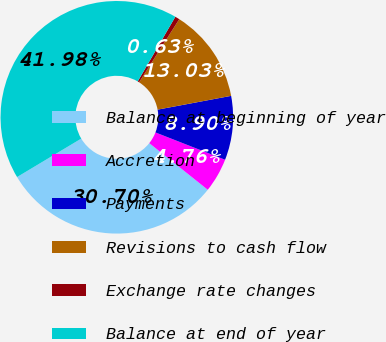Convert chart to OTSL. <chart><loc_0><loc_0><loc_500><loc_500><pie_chart><fcel>Balance at beginning of year<fcel>Accretion<fcel>Payments<fcel>Revisions to cash flow<fcel>Exchange rate changes<fcel>Balance at end of year<nl><fcel>30.7%<fcel>4.76%<fcel>8.9%<fcel>13.03%<fcel>0.63%<fcel>41.98%<nl></chart> 